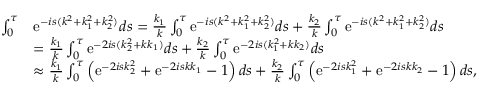Convert formula to latex. <formula><loc_0><loc_0><loc_500><loc_500>\begin{array} { r l } { \int _ { 0 } ^ { \tau } } & { e ^ { - i s ( k ^ { 2 } + k _ { 1 } ^ { 2 } + k _ { 2 } ^ { 2 } ) } d s = \frac { k _ { 1 } } { k } \int _ { 0 } ^ { \tau } e ^ { - i s ( k ^ { 2 } + k _ { 1 } ^ { 2 } + k _ { 2 } ^ { 2 } ) } d s + \frac { k _ { 2 } } { k } \int _ { 0 } ^ { \tau } e ^ { - i s ( k ^ { 2 } + k _ { 1 } ^ { 2 } + k _ { 2 } ^ { 2 } ) } d s } \\ & { = \frac { k _ { 1 } } { k } \int _ { 0 } ^ { \tau } e ^ { - 2 i s ( k _ { 2 } ^ { 2 } + k k _ { 1 } ) } d s + \frac { k _ { 2 } } { k } \int _ { 0 } ^ { \tau } e ^ { - 2 i s ( k _ { 1 } ^ { 2 } + k k _ { 2 } ) } d s } \\ & { \approx \frac { k _ { 1 } } { k } \int _ { 0 } ^ { \tau } \left ( e ^ { - 2 i s k _ { 2 } ^ { 2 } } + e ^ { - 2 i s k k _ { 1 } } - 1 \right ) d s + \frac { k _ { 2 } } { k } \int _ { 0 } ^ { \tau } \left ( e ^ { - 2 i s k _ { 1 } ^ { 2 } } + e ^ { - 2 i s k k _ { 2 } } - 1 \right ) d s , } \end{array}</formula> 